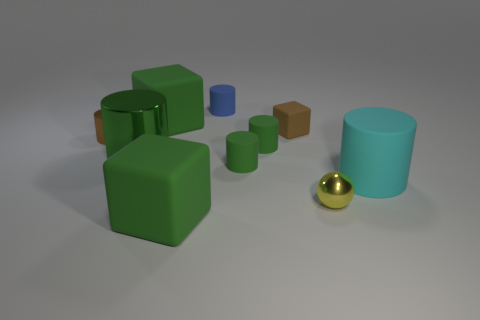What number of big blocks are behind the brown metal cylinder?
Provide a short and direct response. 1. There is a metal object that is on the right side of the matte object left of the rubber object in front of the large cyan object; what size is it?
Your answer should be very brief. Small. There is a tiny brown metal thing; is it the same shape as the thing that is right of the tiny yellow metal sphere?
Give a very brief answer. Yes. The brown thing that is made of the same material as the small blue thing is what size?
Offer a very short reply. Small. Are there any other things of the same color as the large rubber cylinder?
Offer a terse response. No. What material is the big cube left of the green rubber cube right of the large matte block that is behind the large cyan matte cylinder made of?
Provide a short and direct response. Rubber. How many matte things are large cyan balls or tiny cylinders?
Your answer should be compact. 3. Does the small matte block have the same color as the tiny metallic cylinder?
Make the answer very short. Yes. What number of things are cylinders or green matte things that are in front of the cyan matte object?
Give a very brief answer. 7. There is a rubber cube to the right of the blue matte thing; does it have the same size as the cyan rubber cylinder?
Offer a terse response. No. 